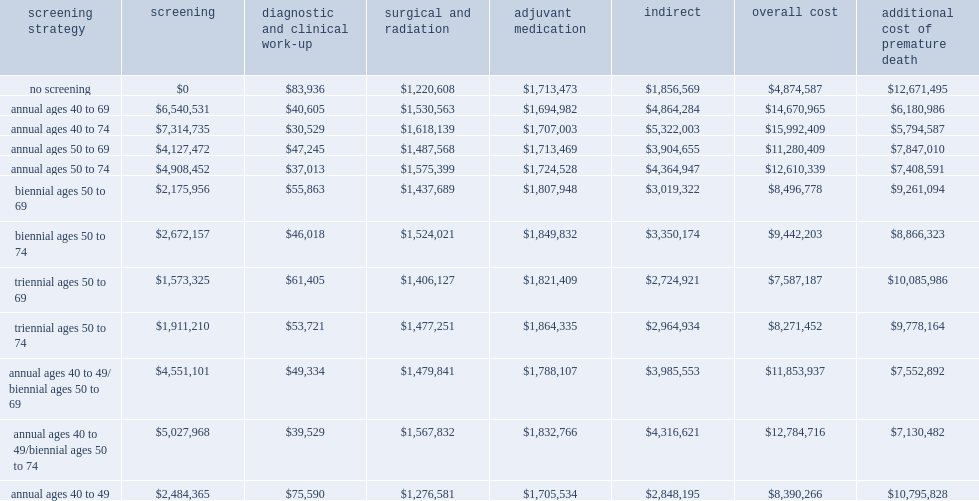What is the range of the overall costs for annual screening of 1,000 women in the general population? $11,280,409 $15,992,409. What is the range of the overall costs for triennial screening of 1,000 women? $7,587,187 $8,271,452. What is the overall cost of no screening for 1,000 women over a lifetime? $4,874,587. 